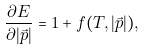Convert formula to latex. <formula><loc_0><loc_0><loc_500><loc_500>\frac { \partial E } { \partial | \vec { p } | } = 1 + f ( T , | \vec { p } | ) ,</formula> 